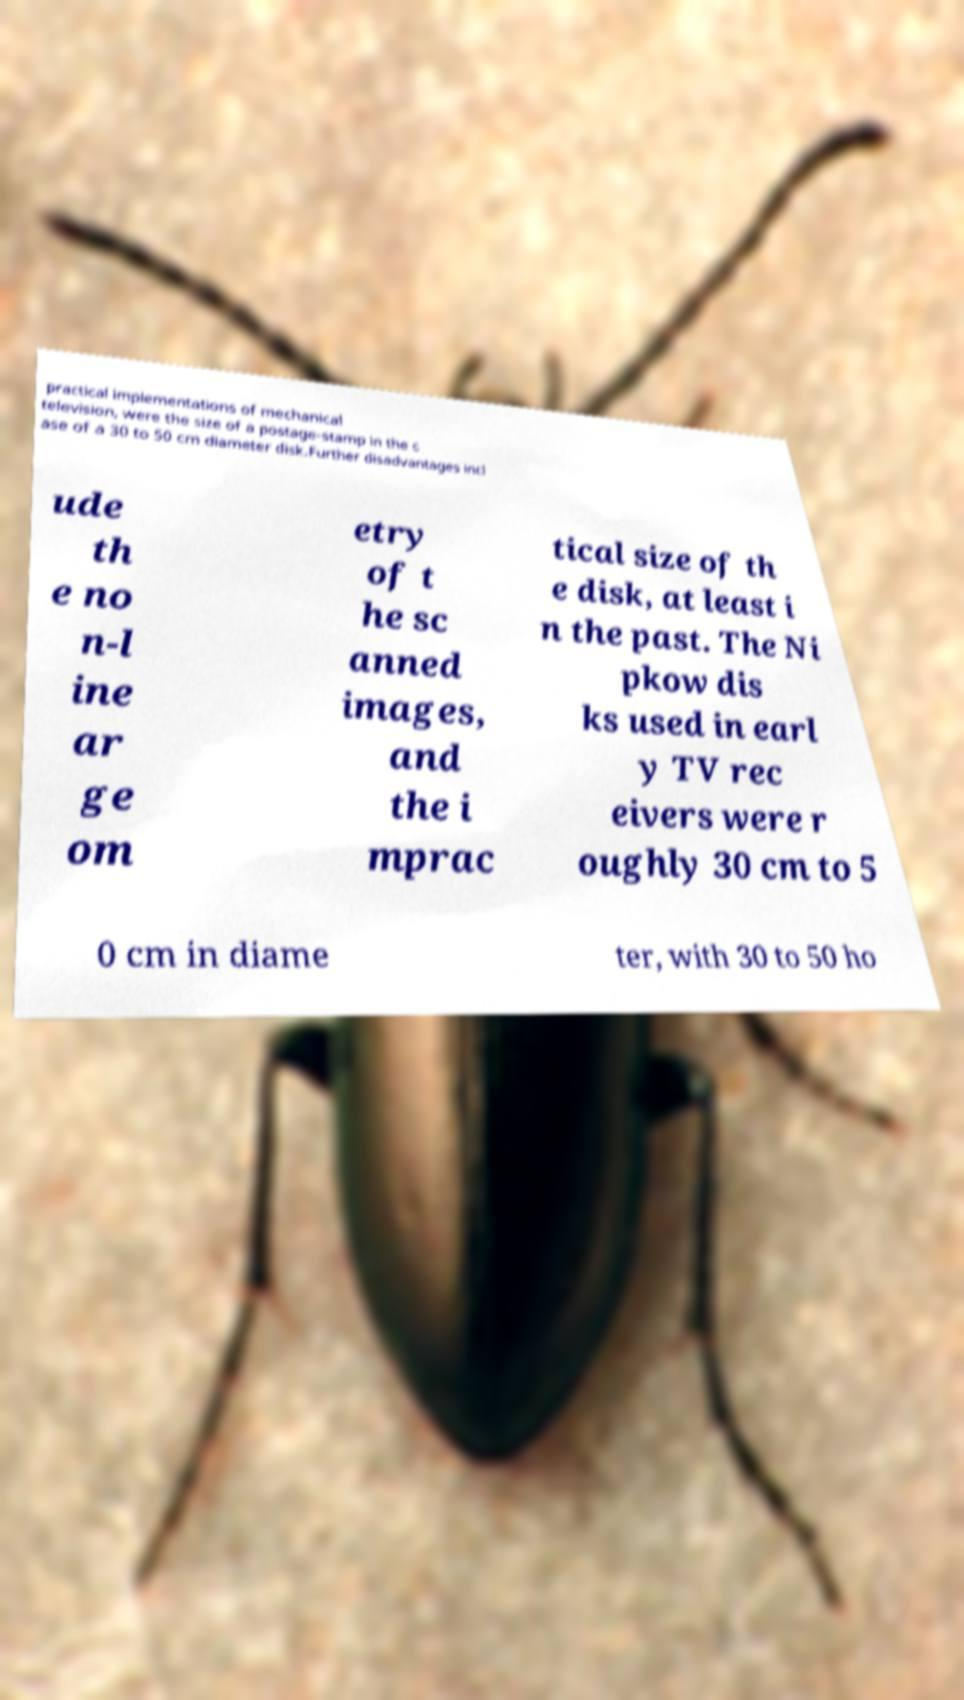I need the written content from this picture converted into text. Can you do that? practical implementations of mechanical television, were the size of a postage-stamp in the c ase of a 30 to 50 cm diameter disk.Further disadvantages incl ude th e no n-l ine ar ge om etry of t he sc anned images, and the i mprac tical size of th e disk, at least i n the past. The Ni pkow dis ks used in earl y TV rec eivers were r oughly 30 cm to 5 0 cm in diame ter, with 30 to 50 ho 